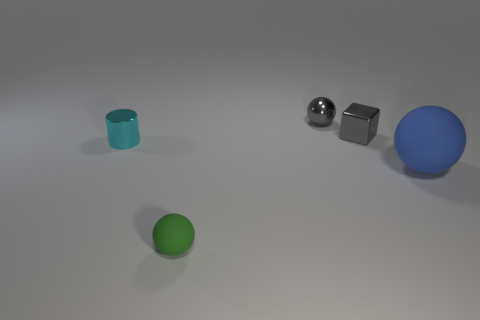Does the tiny sphere behind the tiny metallic block have the same material as the ball on the right side of the small metallic cube?
Offer a terse response. No. Are there fewer small cylinders right of the cyan shiny object than small cyan metallic spheres?
Provide a short and direct response. No. How many blue rubber things are in front of the tiny ball in front of the big blue thing?
Give a very brief answer. 0. How big is the ball that is in front of the gray shiny sphere and left of the blue rubber sphere?
Offer a terse response. Small. Are there any other things that have the same material as the tiny cube?
Offer a terse response. Yes. Does the green object have the same material as the ball to the right of the tiny gray sphere?
Ensure brevity in your answer.  Yes. Are there fewer gray blocks in front of the blue object than tiny gray spheres that are on the left side of the small rubber sphere?
Offer a terse response. No. There is a small sphere behind the big blue sphere; what is it made of?
Keep it short and to the point. Metal. The ball that is both left of the blue sphere and on the right side of the small matte object is what color?
Ensure brevity in your answer.  Gray. How many other objects are the same color as the block?
Provide a short and direct response. 1. 